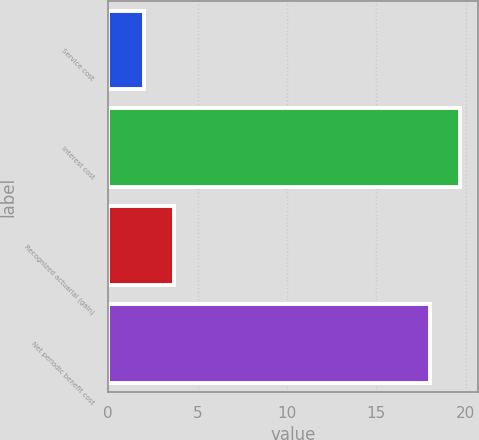Convert chart to OTSL. <chart><loc_0><loc_0><loc_500><loc_500><bar_chart><fcel>Service cost<fcel>Interest cost<fcel>Recognized actuarial (gain)<fcel>Net periodic benefit cost<nl><fcel>2<fcel>19.7<fcel>3.7<fcel>18<nl></chart> 